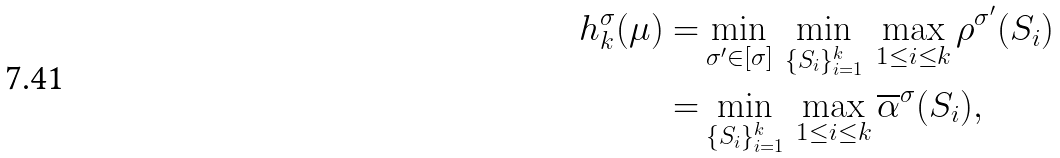Convert formula to latex. <formula><loc_0><loc_0><loc_500><loc_500>h _ { k } ^ { \sigma } ( \mu ) = & \min _ { \sigma ^ { \prime } \in [ \sigma ] } \, \min _ { \{ S _ { i } \} _ { i = 1 } ^ { k } } \, \max _ { 1 \leq i \leq k } \rho ^ { \sigma ^ { \prime } } ( S _ { i } ) \\ = & \min _ { \{ S _ { i } \} _ { i = 1 } ^ { k } } \, \max _ { 1 \leq i \leq k } \overline { \alpha } ^ { \sigma } ( S _ { i } ) ,</formula> 